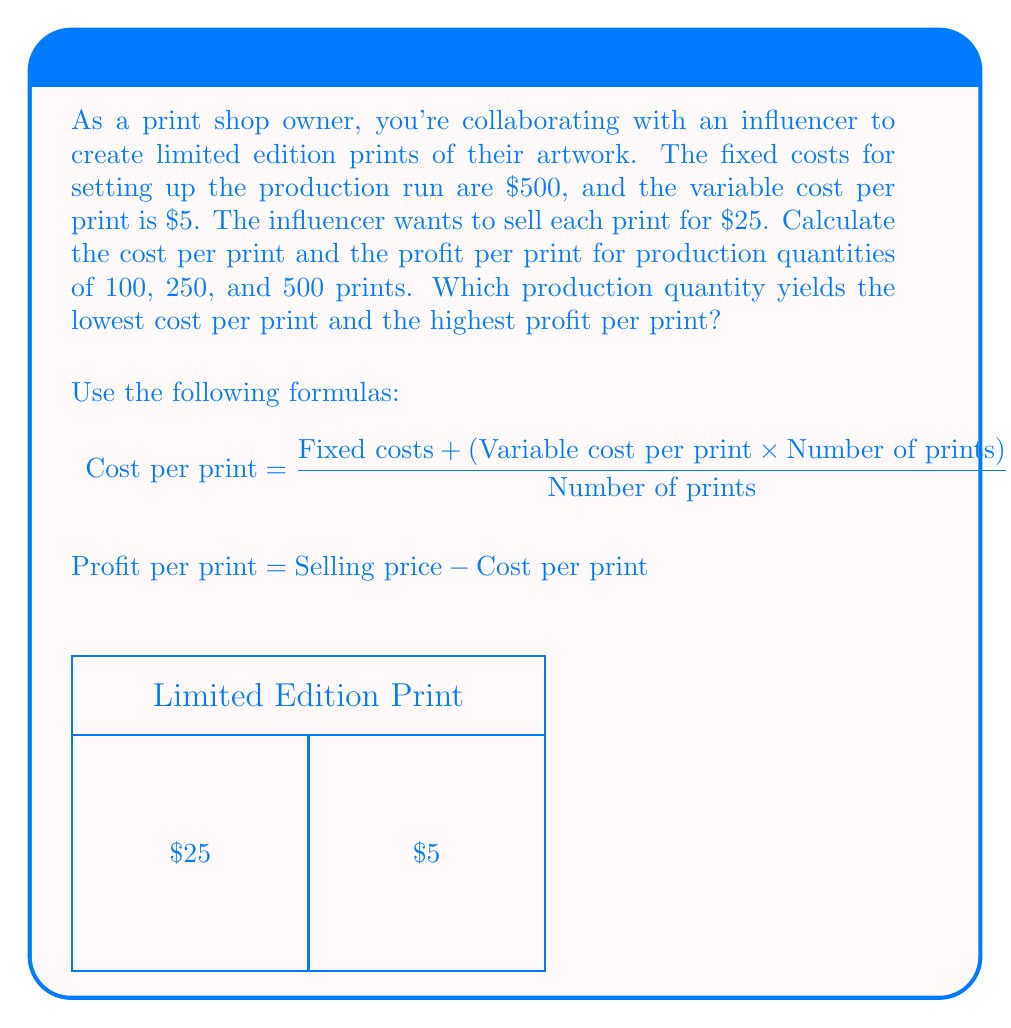Solve this math problem. Let's calculate the cost per print and profit per print for each production quantity:

1. For 100 prints:
   $$\text{Cost per print} = \frac{$500 + ($5 \times 100)}{100} = \frac{$1000}{100} = $10$$
   $$\text{Profit per print} = $25 - $10 = $15$$

2. For 250 prints:
   $$\text{Cost per print} = \frac{$500 + ($5 \times 250)}{250} = \frac{$1750}{250} = $7$$
   $$\text{Profit per print} = $25 - $7 = $18$$

3. For 500 prints:
   $$\text{Cost per print} = \frac{$500 + ($5 \times 500)}{500} = \frac{$3000}{500} = $6$$
   $$\text{Profit per print} = $25 - $6 = $19$$

Comparing the results:
- The lowest cost per print is $6, achieved with 500 prints.
- The highest profit per print is $19, also achieved with 500 prints.

As the production quantity increases, the fixed costs are spread over more prints, resulting in a lower cost per print and a higher profit per print.
Answer: 500 prints: $6 cost/print, $19 profit/print 